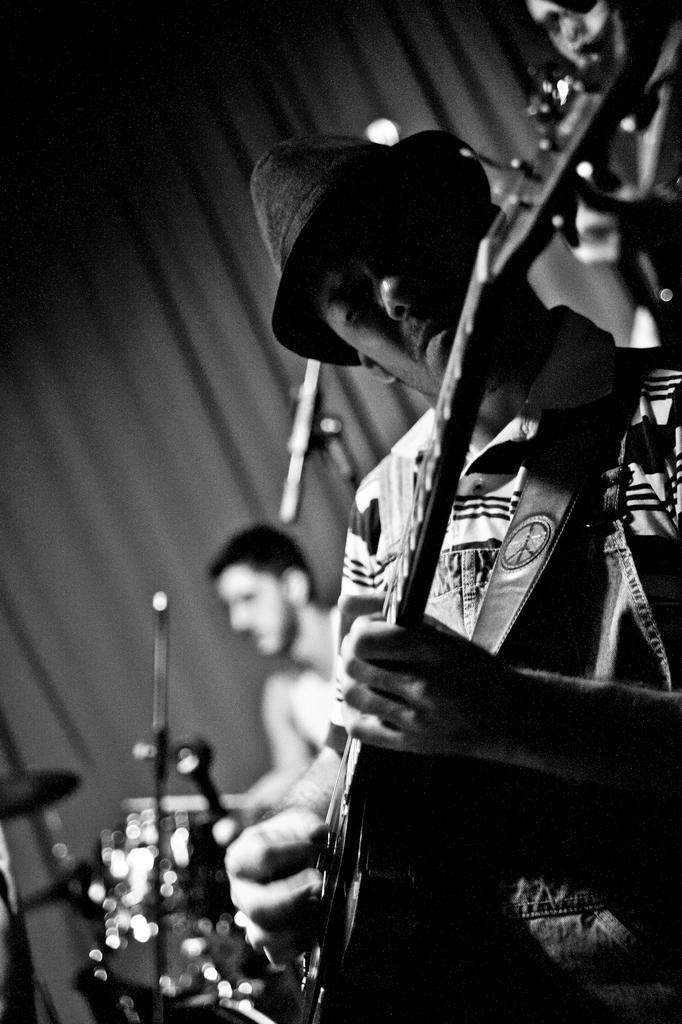Can you describe this image briefly? In the picture there are many people playing different musical instruments. 